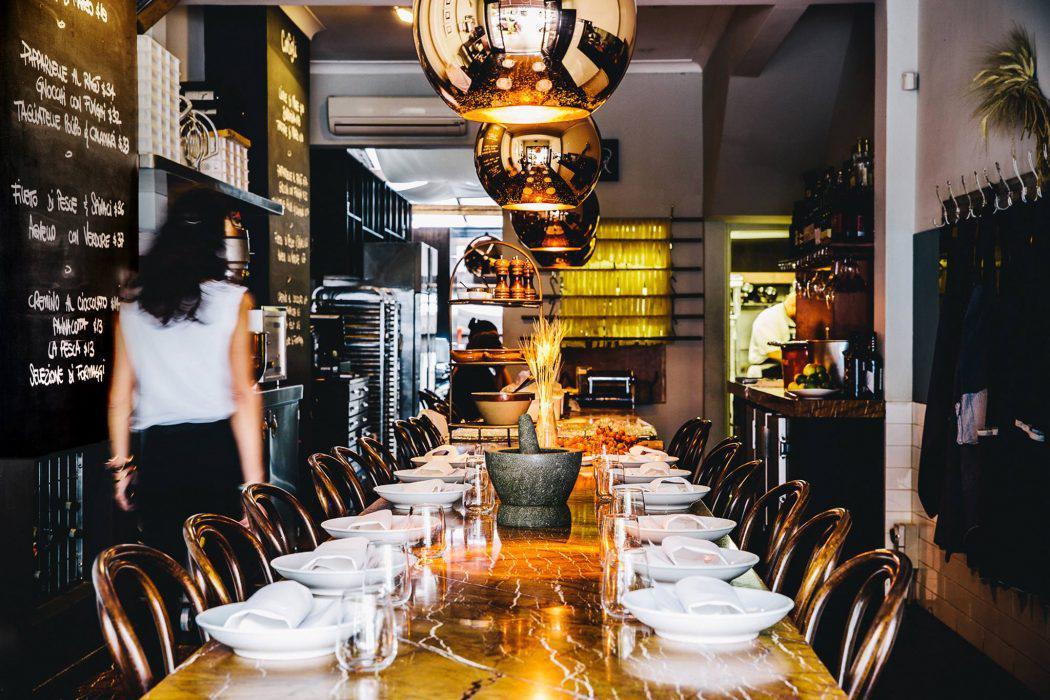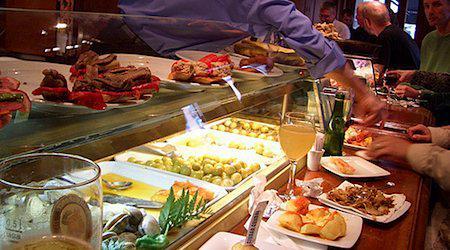The first image is the image on the left, the second image is the image on the right. Assess this claim about the two images: "Hands are poised over a plate of food on a brown table holding multiple white plates in the right image.". Correct or not? Answer yes or no. Yes. 